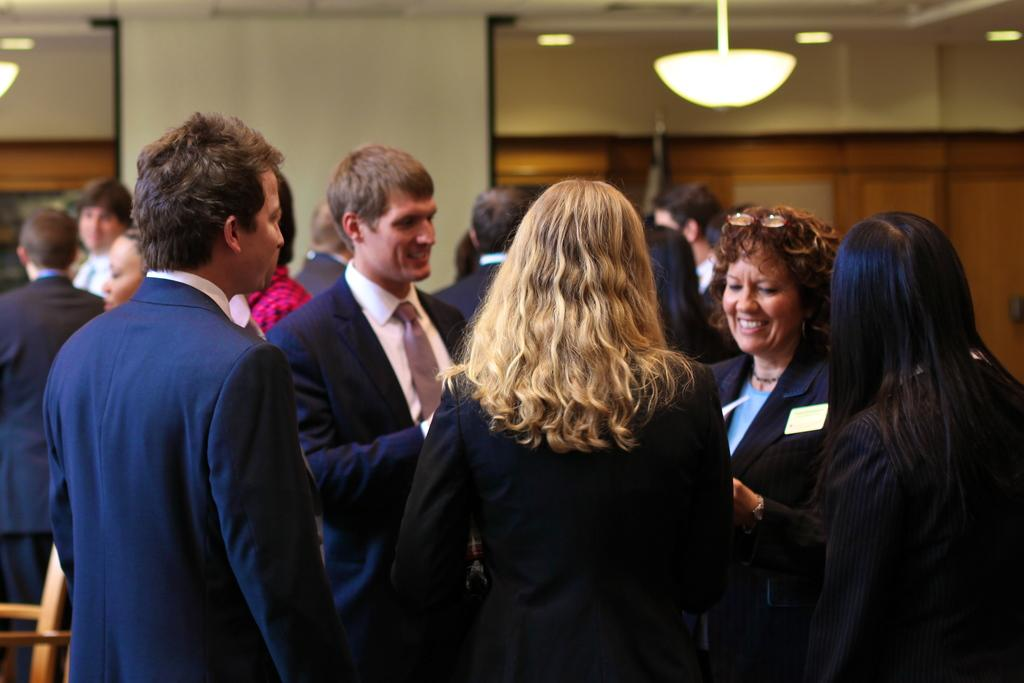What can be seen in the foreground of the image? There are people in the foreground of the image. What is visible in the background of the image? There are doors and lamps in the background of the image. How many times do the people in the image kick the edge of the doors? There is no indication in the image that the people are kicking the doors or that there is any interaction between the people and the doors. 